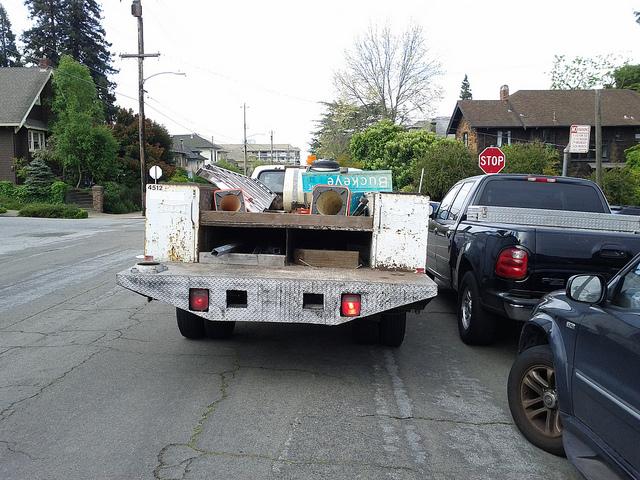Are the cars moving?
Short answer required. No. How many tires are visible in the image?
Give a very brief answer. 4. How many lanes can be seen?
Short answer required. 2. What sign is picture in the photograph?
Answer briefly. Stop. 